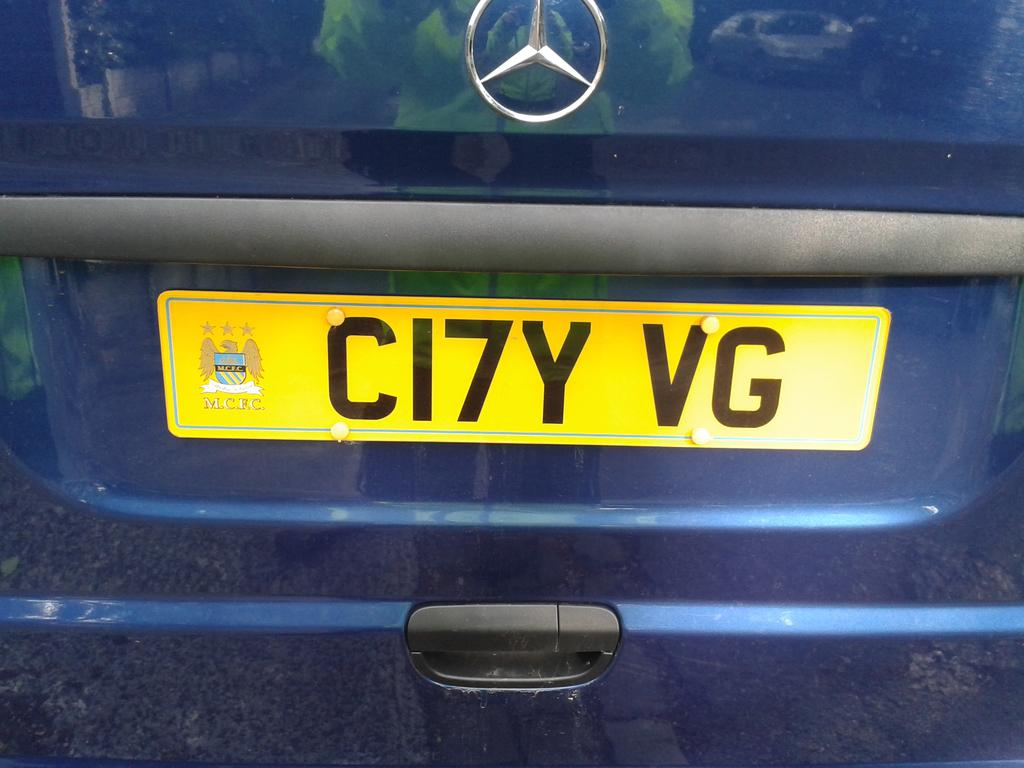<image>
Create a compact narrative representing the image presented. a ci7y vg name on a license plate 